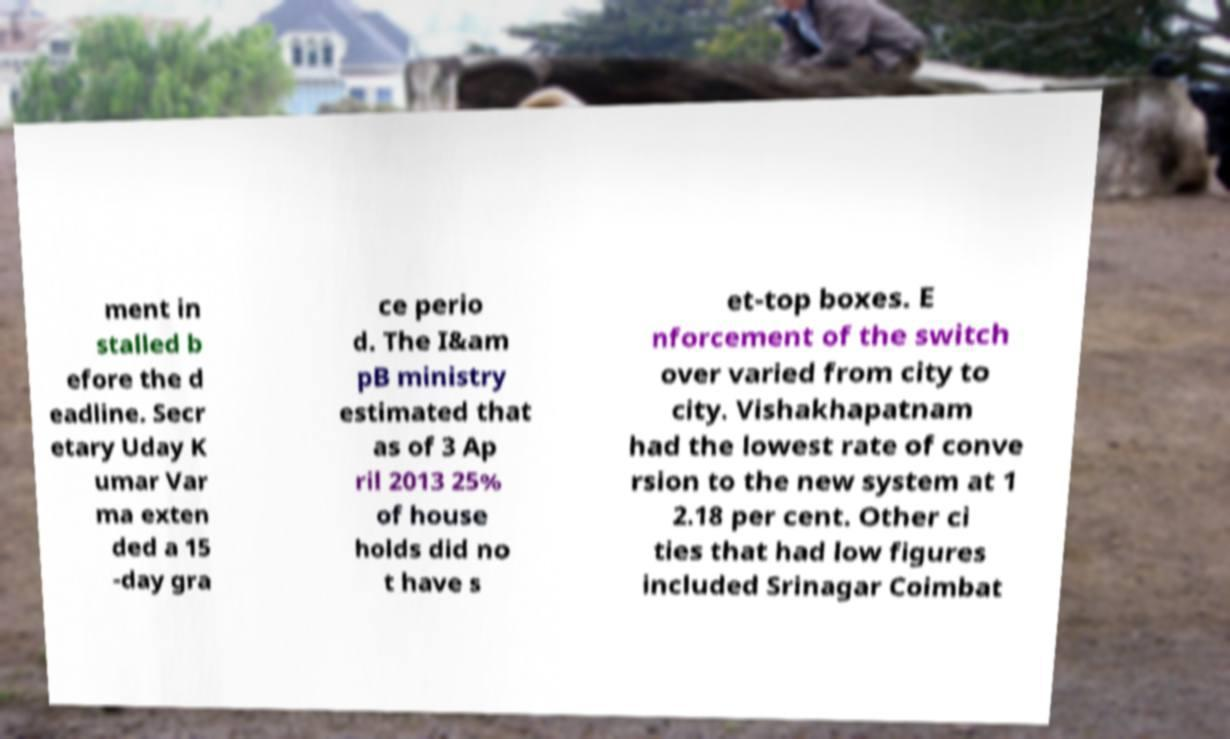For documentation purposes, I need the text within this image transcribed. Could you provide that? ment in stalled b efore the d eadline. Secr etary Uday K umar Var ma exten ded a 15 -day gra ce perio d. The I&am pB ministry estimated that as of 3 Ap ril 2013 25% of house holds did no t have s et-top boxes. E nforcement of the switch over varied from city to city. Vishakhapatnam had the lowest rate of conve rsion to the new system at 1 2.18 per cent. Other ci ties that had low figures included Srinagar Coimbat 